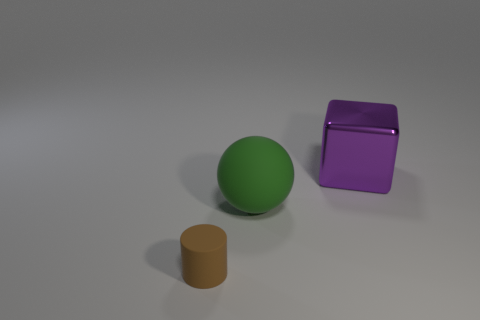Is there a matte object in front of the big object that is on the left side of the large purple metal object?
Keep it short and to the point. Yes. There is a large thing on the right side of the large thing in front of the large purple thing; what number of matte things are right of it?
Offer a very short reply. 0. Is the number of cylinders less than the number of yellow rubber blocks?
Provide a succinct answer. No. There is a thing that is in front of the large matte thing; does it have the same shape as the thing on the right side of the green rubber object?
Make the answer very short. No. What is the color of the metal object?
Your answer should be compact. Purple. How many matte things are balls or purple objects?
Ensure brevity in your answer.  1. Are there any big cyan balls?
Offer a terse response. No. Are the big thing in front of the big purple thing and the thing in front of the green thing made of the same material?
Keep it short and to the point. Yes. How many objects are objects that are behind the brown cylinder or large objects in front of the big purple cube?
Offer a very short reply. 2. Do the big thing to the left of the big shiny cube and the big object on the right side of the big green matte sphere have the same color?
Provide a short and direct response. No. 